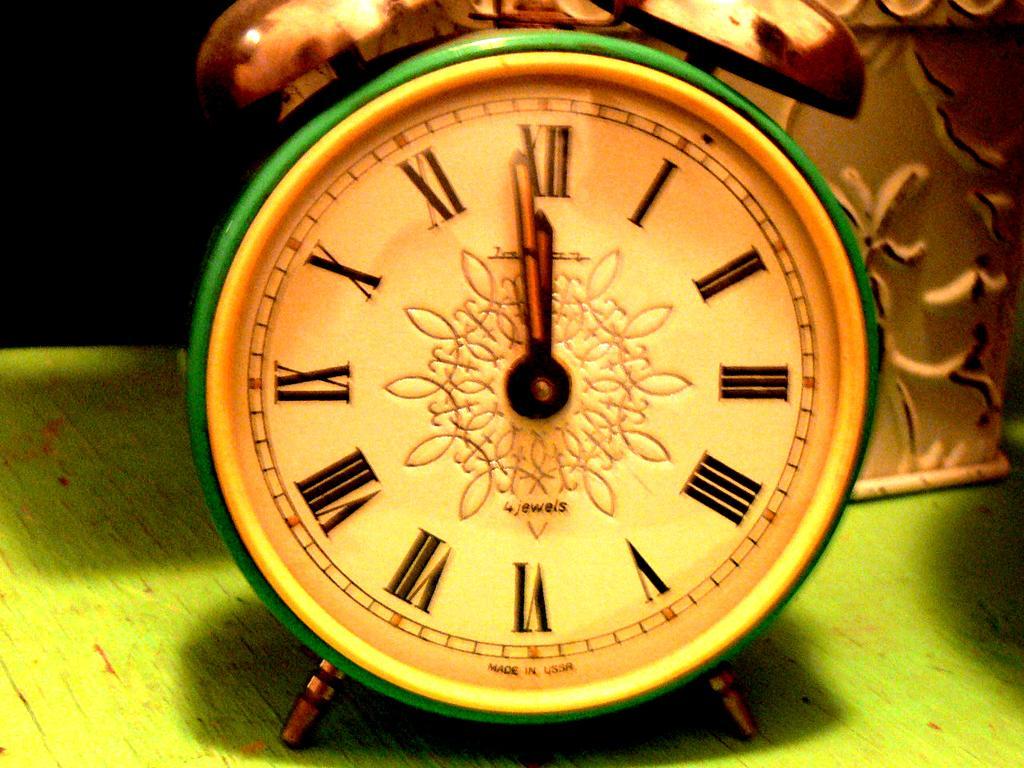Can you describe this image briefly? In the image on the green surface there is an alarm clock. Behind the alarm clock there is an item with design. 